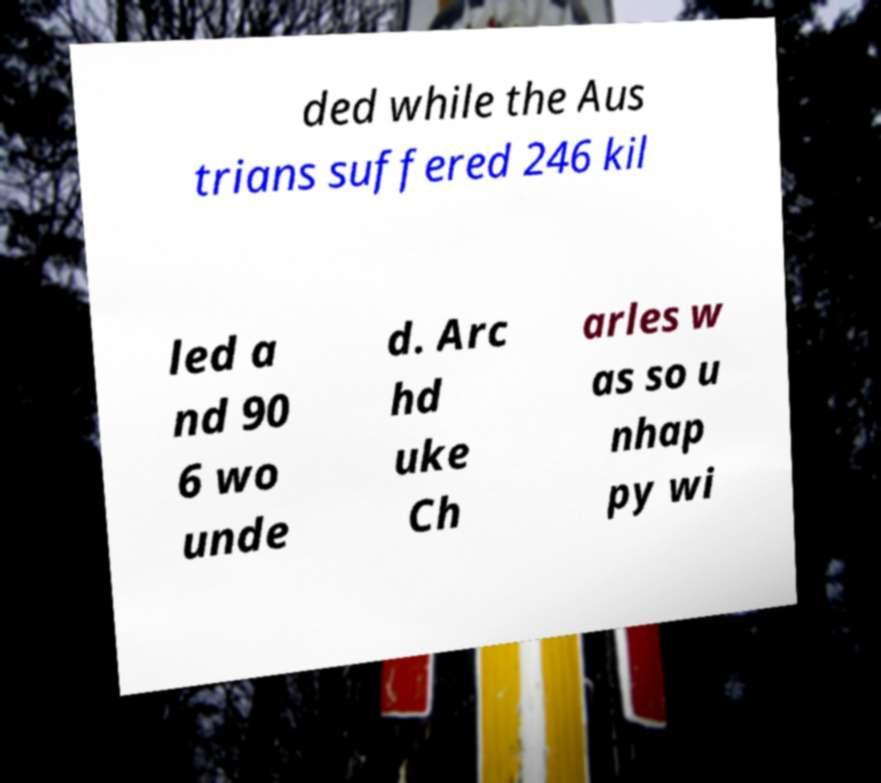For documentation purposes, I need the text within this image transcribed. Could you provide that? ded while the Aus trians suffered 246 kil led a nd 90 6 wo unde d. Arc hd uke Ch arles w as so u nhap py wi 